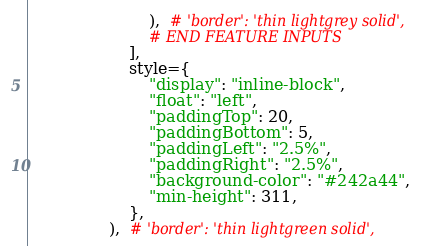<code> <loc_0><loc_0><loc_500><loc_500><_Python_>                        ),  # 'border': 'thin lightgrey solid',
                        # END FEATURE INPUTS
                    ],
                    style={
                        "display": "inline-block",
                        "float": "left",
                        "paddingTop": 20,
                        "paddingBottom": 5,
                        "paddingLeft": "2.5%",
                        "paddingRight": "2.5%",
                        "background-color": "#242a44",
                        "min-height": 311,
                    },
                ),  # 'border': 'thin lightgreen solid',</code> 